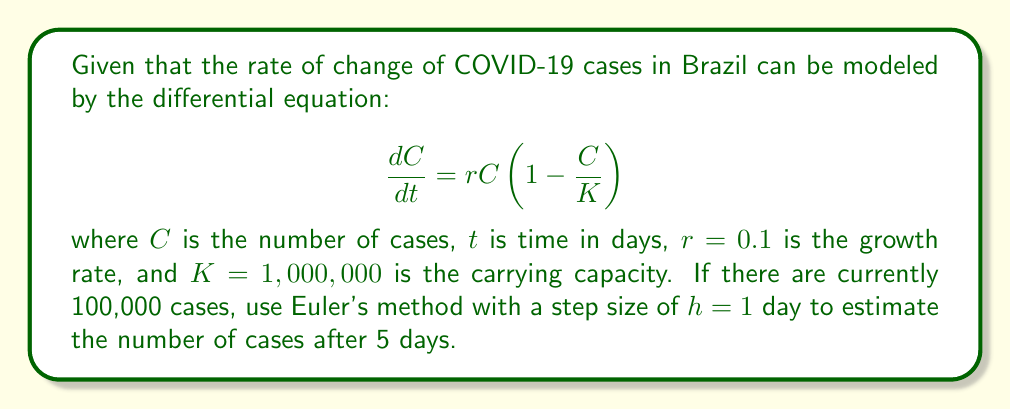Could you help me with this problem? To solve this problem, we'll use Euler's method, which is a numerical method for solving differential equations. The formula for Euler's method is:

$$C_{n+1} = C_n + h \cdot f(C_n)$$

where $f(C) = \frac{dC}{dt} = rC(1 - \frac{C}{K})$

Given:
- Initial number of cases: $C_0 = 100,000$
- Growth rate: $r = 0.1$
- Carrying capacity: $K = 1,000,000$
- Step size: $h = 1$ day
- Number of steps: 5 (for 5 days)

Let's calculate step by step:

1) For day 1:
   $f(C_0) = 0.1 \cdot 100,000 \cdot (1 - \frac{100,000}{1,000,000}) = 9,000$
   $C_1 = 100,000 + 1 \cdot 9,000 = 109,000$

2) For day 2:
   $f(C_1) = 0.1 \cdot 109,000 \cdot (1 - \frac{109,000}{1,000,000}) = 9,729.1$
   $C_2 = 109,000 + 1 \cdot 9,729.1 = 118,729.1$

3) For day 3:
   $f(C_2) = 0.1 \cdot 118,729.1 \cdot (1 - \frac{118,729.1}{1,000,000}) = 10,411.7$
   $C_3 = 118,729.1 + 1 \cdot 10,411.7 = 129,140.8$

4) For day 4:
   $f(C_3) = 0.1 \cdot 129,140.8 \cdot (1 - \frac{129,140.8}{1,000,000}) = 11,042.8$
   $C_4 = 129,140.8 + 1 \cdot 11,042.8 = 140,183.6$

5) For day 5:
   $f(C_4) = 0.1 \cdot 140,183.6 \cdot (1 - \frac{140,183.6}{1,000,000}) = 11,617.7$
   $C_5 = 140,183.6 + 1 \cdot 11,617.7 = 151,801.3$

Therefore, after 5 days, the estimated number of cases is approximately 151,801.
Answer: 151,801 cases 